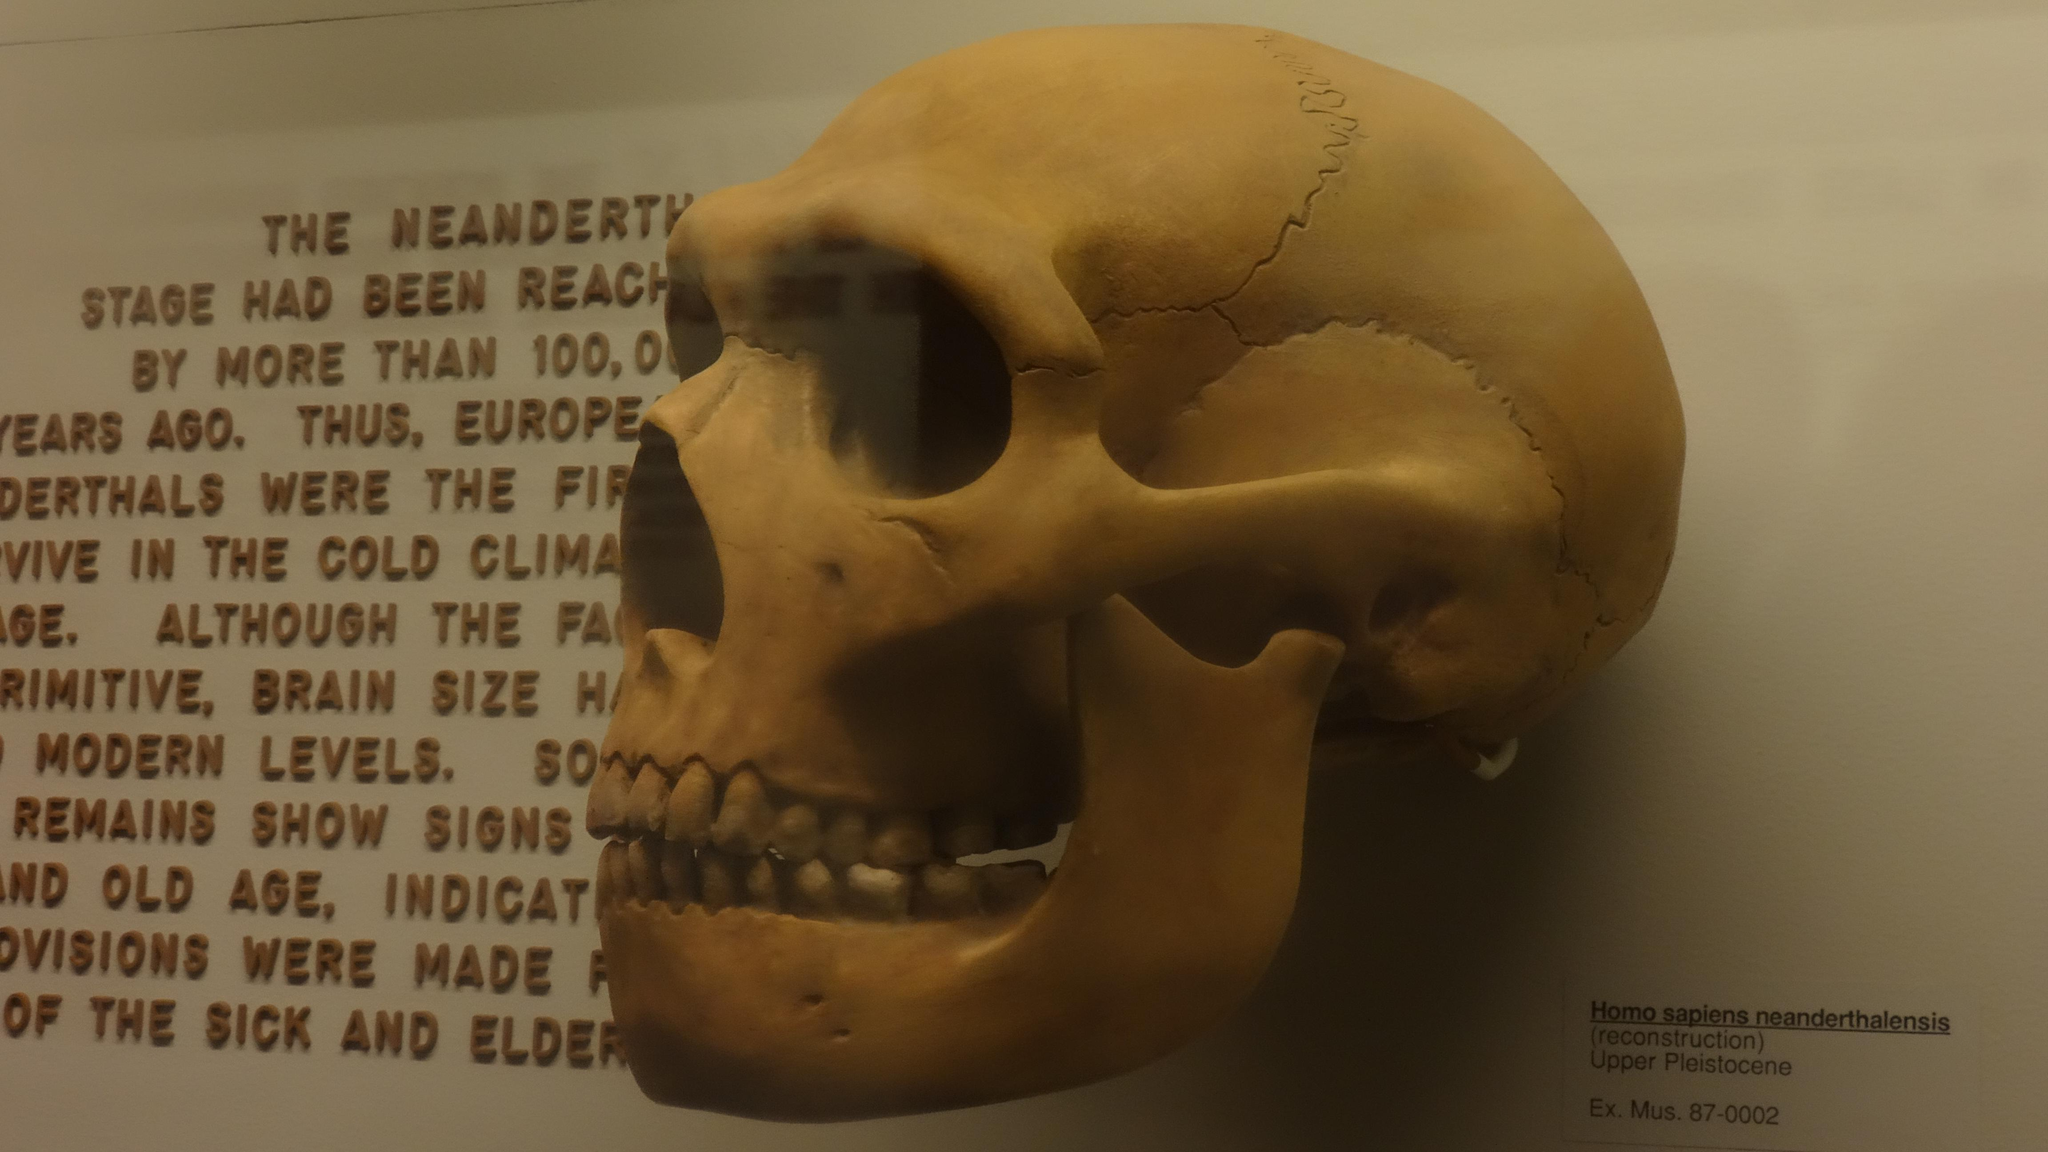What is the main subject of the image? The main subject of the image is a skull. Is there any text present in the image? Yes, there is text on the left side of the image. What type of grain is being served at the party in the image? There is no party or grain present in the image; it features a skull and text. How many corks are visible in the image? There are no corks present in the image. 